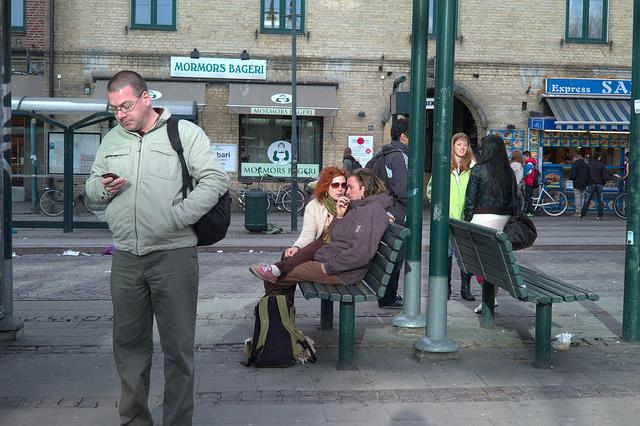What type of shop is the one with the woman's picture in a circle on the window? Please explain your reasoning. bakery. This is swedish for "bakery". 